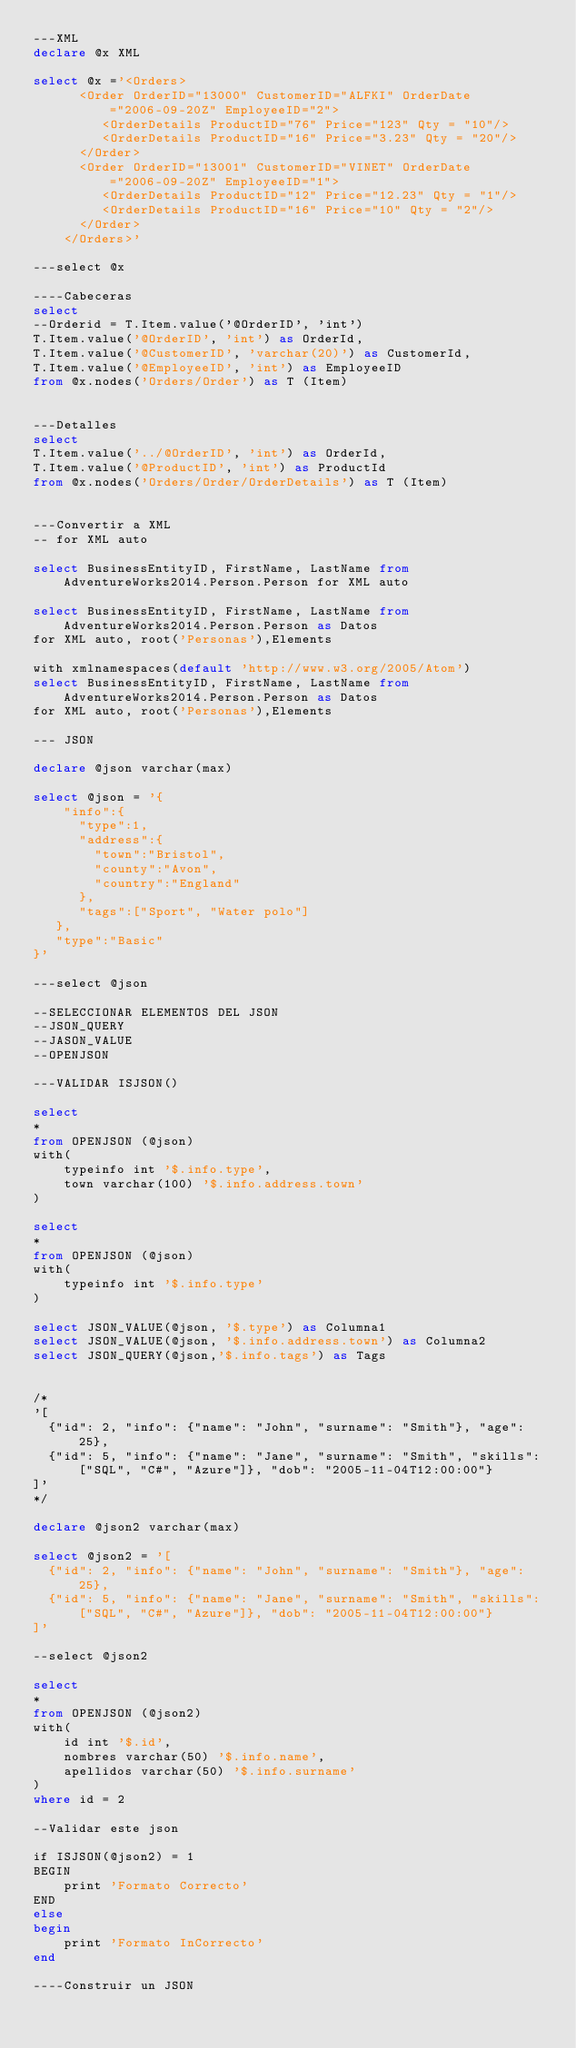Convert code to text. <code><loc_0><loc_0><loc_500><loc_500><_SQL_>---XML
declare @x XML

select @x ='<Orders>
      <Order OrderID="13000" CustomerID="ALFKI" OrderDate="2006-09-20Z" EmployeeID="2">
         <OrderDetails ProductID="76" Price="123" Qty = "10"/>
         <OrderDetails ProductID="16" Price="3.23" Qty = "20"/>
      </Order>
      <Order OrderID="13001" CustomerID="VINET" OrderDate="2006-09-20Z" EmployeeID="1">
         <OrderDetails ProductID="12" Price="12.23" Qty = "1"/>
		 <OrderDetails ProductID="16" Price="10" Qty = "2"/>
      </Order>
    </Orders>'

---select @x

----Cabeceras
select
--Orderid = T.Item.value('@OrderID', 'int')
T.Item.value('@OrderID', 'int') as OrderId,
T.Item.value('@CustomerID', 'varchar(20)') as CustomerId,
T.Item.value('@EmployeeID', 'int') as EmployeeID
from @x.nodes('Orders/Order') as T (Item)


---Detalles
select
T.Item.value('../@OrderID', 'int') as OrderId,
T.Item.value('@ProductID', 'int') as ProductId
from @x.nodes('Orders/Order/OrderDetails') as T (Item)


---Convertir a XML
-- for XML auto

select BusinessEntityID, FirstName, LastName from AdventureWorks2014.Person.Person for XML auto

select BusinessEntityID, FirstName, LastName from AdventureWorks2014.Person.Person as Datos
for XML auto, root('Personas'),Elements

with xmlnamespaces(default 'http://www.w3.org/2005/Atom')
select BusinessEntityID, FirstName, LastName from AdventureWorks2014.Person.Person as Datos
for XML auto, root('Personas'),Elements

--- JSON

declare @json varchar(max)

select @json = '{    "info":{        "type":1,      "address":{          "town":"Bristol",        "county":"Avon",        "country":"England"      },      "tags":["Sport", "Water polo"]   },   "type":"Basic"}'---select @json --SELECCIONAR ELEMENTOS DEL JSON--JSON_QUERY--JASON_VALUE--OPENJSON---VALIDAR ISJSON()select *from OPENJSON (@json)with(	typeinfo int '$.info.type',	town varchar(100) '$.info.address.town')select *from OPENJSON (@json)with(	typeinfo int '$.info.type')select JSON_VALUE(@json, '$.type') as Columna1select JSON_VALUE(@json, '$.info.address.town') as Columna2select JSON_QUERY(@json,'$.info.tags') as Tags/*'[    {"id": 2, "info": {"name": "John", "surname": "Smith"}, "age": 25},  {"id": 5, "info": {"name": "Jane", "surname": "Smith", "skills": ["SQL", "C#", "Azure"]}, "dob": "2005-11-04T12:00:00"}  ]'
*/

declare @json2 varchar(max)

select @json2 = '[    {"id": 2, "info": {"name": "John", "surname": "Smith"}, "age": 25},  {"id": 5, "info": {"name": "Jane", "surname": "Smith", "skills": ["SQL", "C#", "Azure"]}, "dob": "2005-11-04T12:00:00"}  ]'

--select @json2

select *from OPENJSON (@json2)with(	id int '$.id',	nombres varchar(50) '$.info.name',	apellidos varchar(50) '$.info.surname')where id = 2

--Validar este json

if ISJSON(@json2) = 1
BEGIN
	print 'Formato Correcto'
END
else
begin
	print 'Formato InCorrecto'
end

----Construir un JSON
</code> 